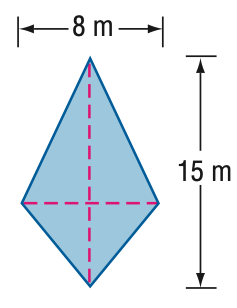Answer the mathemtical geometry problem and directly provide the correct option letter.
Question: Find the area of the kite.
Choices: A: 40 B: 60 C: 80 D: 120 B 